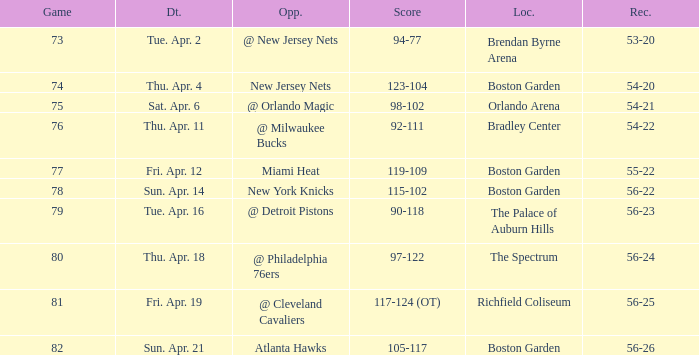When was the score 56-26? Sun. Apr. 21. 